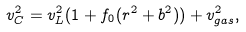<formula> <loc_0><loc_0><loc_500><loc_500>v _ { C } ^ { 2 } = v _ { L } ^ { 2 } ( 1 + f _ { 0 } ( r ^ { 2 } + b ^ { 2 } ) ) + v _ { g a s } ^ { 2 } ,</formula> 